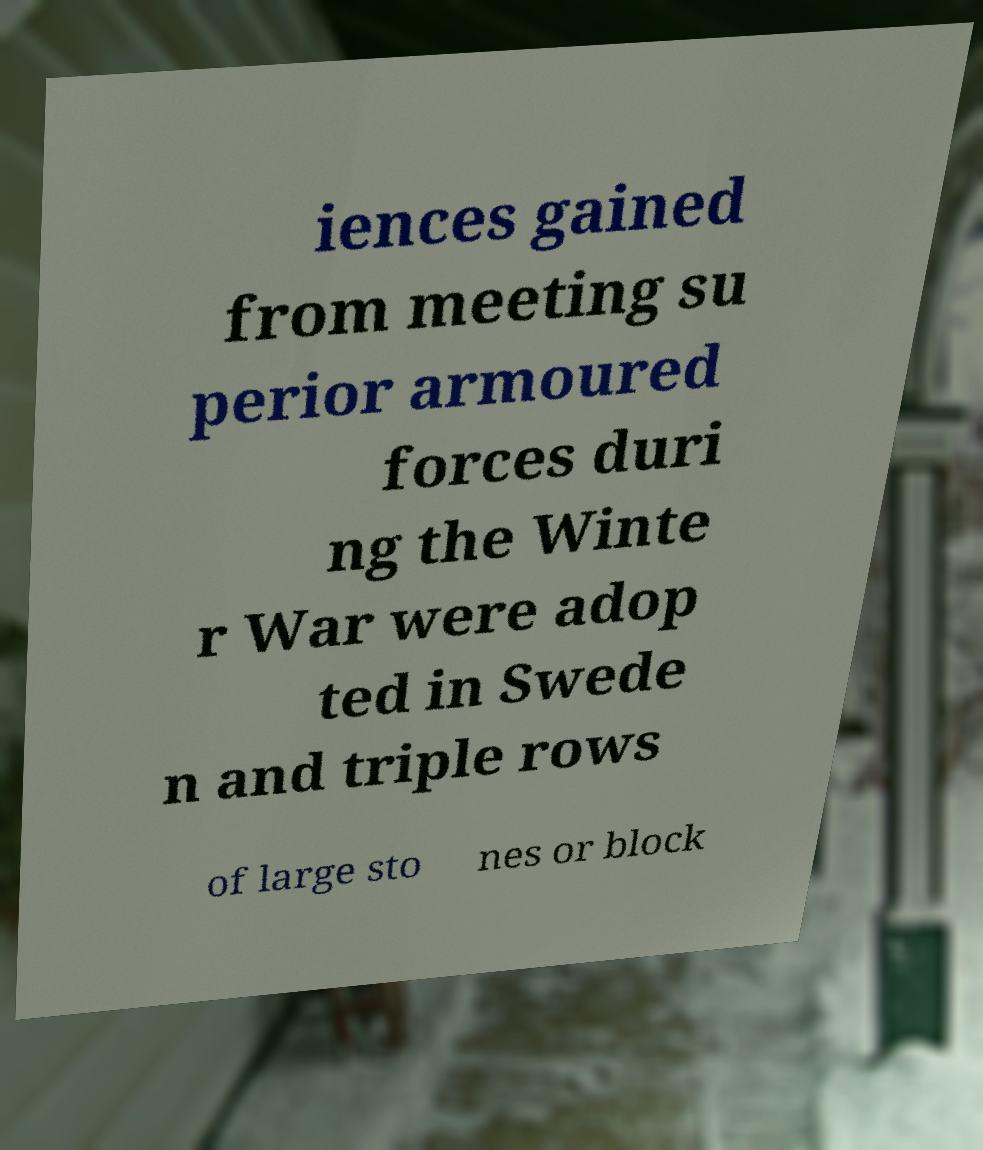Could you extract and type out the text from this image? iences gained from meeting su perior armoured forces duri ng the Winte r War were adop ted in Swede n and triple rows of large sto nes or block 